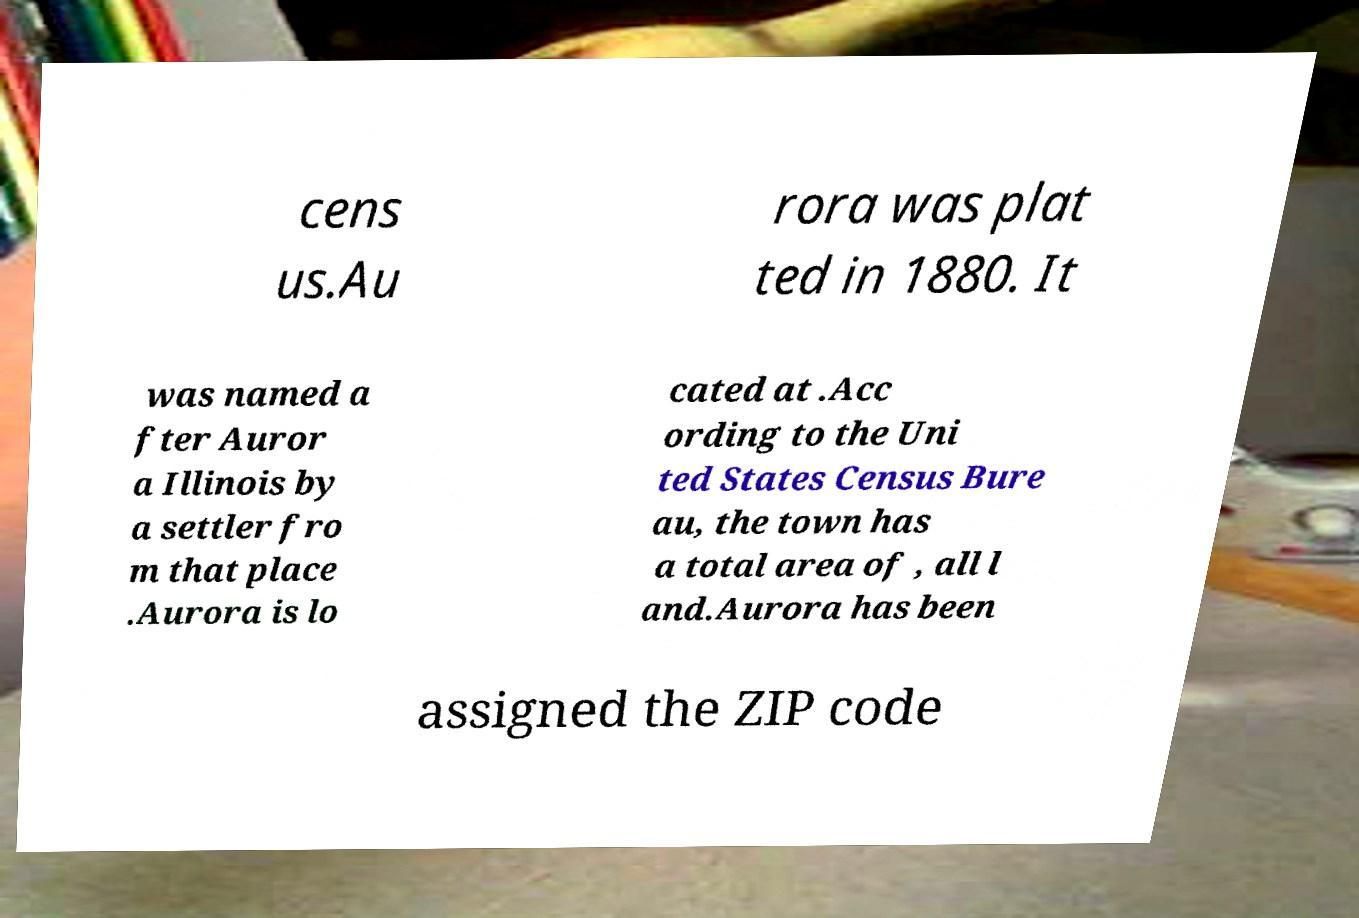Can you read and provide the text displayed in the image?This photo seems to have some interesting text. Can you extract and type it out for me? cens us.Au rora was plat ted in 1880. It was named a fter Auror a Illinois by a settler fro m that place .Aurora is lo cated at .Acc ording to the Uni ted States Census Bure au, the town has a total area of , all l and.Aurora has been assigned the ZIP code 